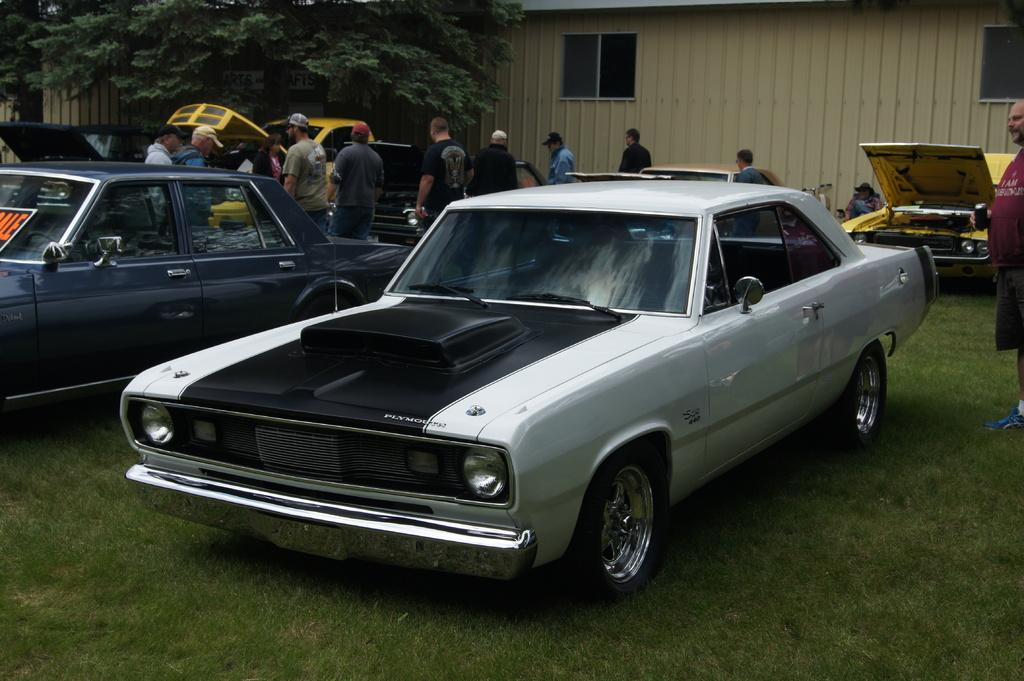What type of environment is depicted in the image? The image is an outside view. What can be seen on the ground in the image? There are cars on the ground. Are there any people visible in the image? Yes, there are people standing in the image. What is the ground covered with? The ground has grass. What structures can be seen in the background of the image? There is a shed in the background. What type of vegetation is present in the background? Trees are present in the background. Can you see any snails crawling on the grass in the image? There is no snail visible in the image. What type of clouds can be seen in the sky in the image? The image does not show the sky, so it is not possible to determine if there are clouds present. 